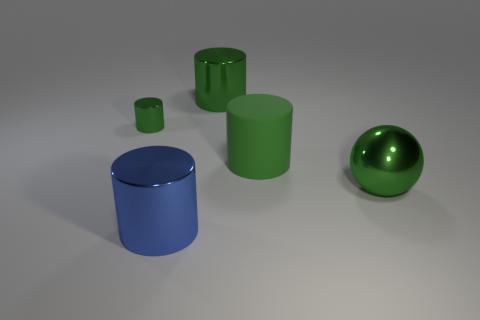Subtract all red cubes. How many green cylinders are left? 3 Subtract all blue cylinders. How many cylinders are left? 3 Subtract all large cylinders. How many cylinders are left? 1 Add 5 green metallic cylinders. How many objects exist? 10 Subtract all brown cylinders. Subtract all green cubes. How many cylinders are left? 4 Subtract all cylinders. How many objects are left? 1 Add 5 cylinders. How many cylinders exist? 9 Subtract 0 brown balls. How many objects are left? 5 Subtract all tiny green things. Subtract all green objects. How many objects are left? 0 Add 3 large blue cylinders. How many large blue cylinders are left? 4 